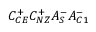<formula> <loc_0><loc_0><loc_500><loc_500>C _ { C E } ^ { + } C _ { N Z } ^ { + } A _ { S } ^ { - } A _ { C 1 } ^ { - }</formula> 